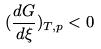Convert formula to latex. <formula><loc_0><loc_0><loc_500><loc_500>( \frac { d G } { d \xi } ) _ { T , p } < 0</formula> 